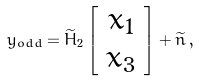Convert formula to latex. <formula><loc_0><loc_0><loc_500><loc_500>y _ { o d d } = \widetilde { H } _ { 2 } \left [ \begin{array} { c } x _ { 1 } \\ x _ { 3 } \\ \end{array} \right ] + \widetilde { n } \, ,</formula> 